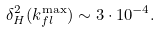Convert formula to latex. <formula><loc_0><loc_0><loc_500><loc_500>\delta _ { H } ^ { 2 } ( k _ { f l } ^ { \max } ) \sim 3 \cdot 1 0 ^ { - 4 } .</formula> 